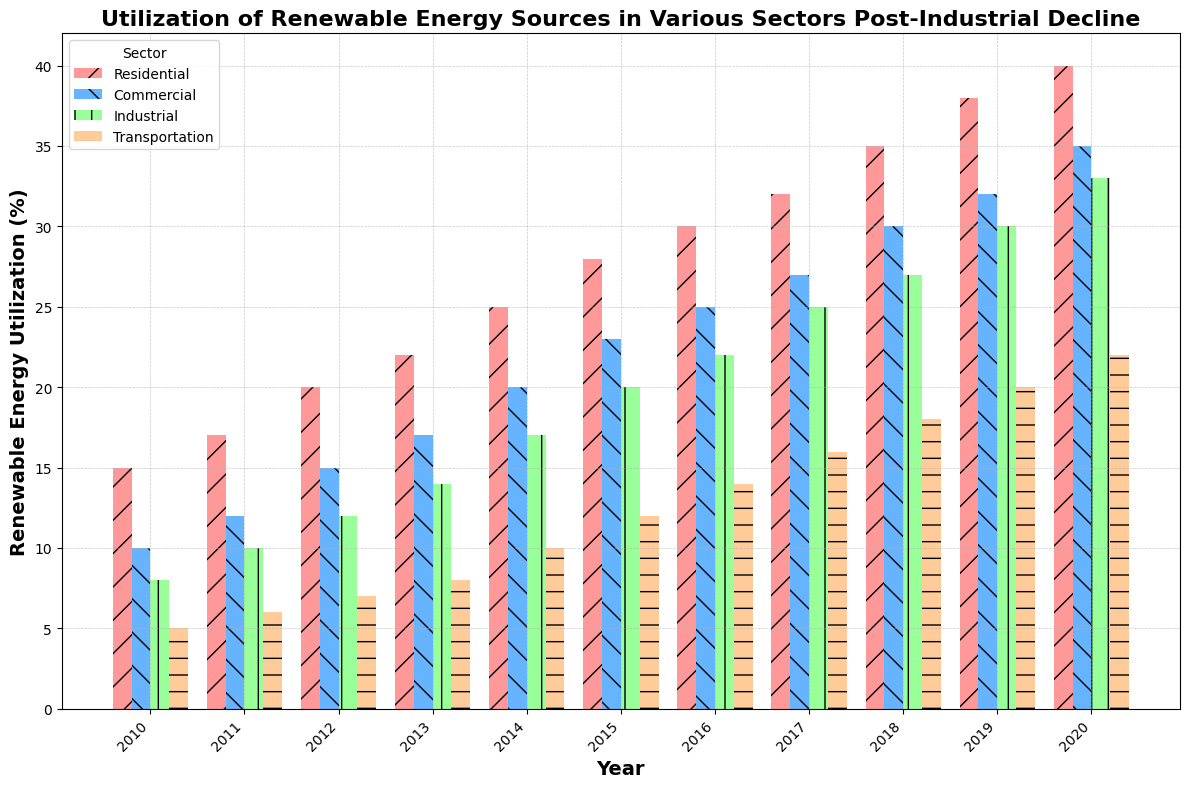What is the trend of renewable energy utilization in the Transportation sector from 2010 to 2020? To determine the trend, we look at the heights of the bars corresponding to the Transportation sector across the years. From 2010 to 2020, the bars gradually increase in height, indicating a steady rise in renewable energy utilization.
Answer: Steadily increasing Which sector had the highest percentage of renewable energy utilization in 2020? By comparing the heights of all the bars in the year 2020, we observe that the Residential sector has the tallest bar, signifying the highest percentage of renewable energy utilization.
Answer: Residential What is the difference in renewable energy utilization between the Residential and Industrial sectors in 2015? To determine the difference, we look at the heights of the bars for the Residential and Industrial sectors in 2015. The Residential sector bar is at 28%, and the Industrial sector bar is at 20%. Subtracting 20 from 28 gives us the difference of 8%.
Answer: 8% How does the growth in renewable energy utilization in the Commercial sector from 2010 to 2020 compare to that in the Transportation sector? To compare the growth, we calculate the difference in utilization percentages from 2010 to 2020 for both sectors: 35% (2020) - 10% (2010) = 25% for Commercial, and 22% (2020) - 5% (2010) = 17% for Transportation. The increase in the Commercial sector is greater by 8%.
Answer: The Commercial sector had an 8% greater increase Which year showed the largest increase in renewable energy utilization in the Industrial sector compared to the previous year? To identify the largest increase, compare the differences in percentages year-over-year for the Industrial sector. From 2010 to 2020, the largest increase is between 2014 (17%) and 2015 (20%) with a 3% rise.
Answer: Between 2014 and 2015 In what year did the Residential sector first surpass 30% renewable energy utilization? Reviewing the Residential sector bars' heights, the first year the utilization surpasses 30% is 2016. In this year, the height is at 30%. From 2017 onwards, it's above 30%.
Answer: 2016 Which sector showed the least improvement in renewable energy utilization from 2010 to 2020? Analyzing the differences in bar heights from 2010 to 2020 across all sectors, the Transportation sector shows the smallest increase: 22% (2020) - 5% (2010) = 17%.
Answer: Transportation What is the average percentage of renewable energy utilization for the Industrial sector over the decade? Calculate the mean of the percentages for the Industrial sector from 2010 to 2020: (8+10+12+14+17+20+22+25+27+30+33)/11 = 20.55%.
Answer: 20.55% Between which two consecutive years did the Residential sector show the smallest change in renewable energy utilization? Comparing year-over-year changes for the Residential sector, the smallest change is between 2016 (30%) and 2017 (32%), which is a 2% increase.
Answer: Between 2016 and 2017 